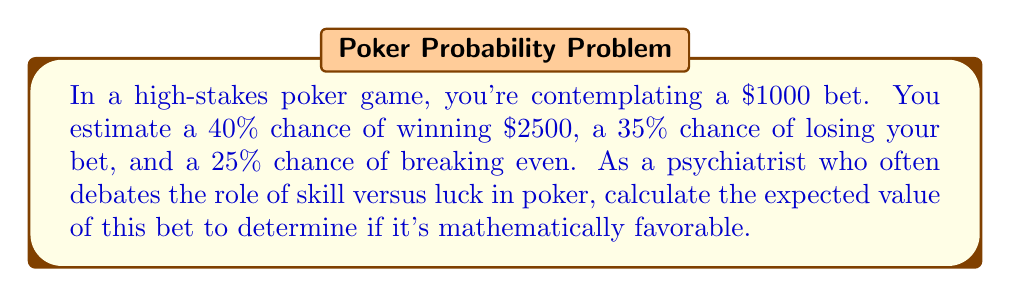Solve this math problem. Let's approach this step-by-step:

1) First, let's define the expected value (EV) formula:
   $$ EV = \sum_{i=1}^n p_i \cdot v_i $$
   where $p_i$ is the probability of each outcome and $v_i$ is the value of each outcome.

2) We have three possible outcomes:
   a) Win: 40% chance of winning $2500
   b) Lose: 35% chance of losing $1000
   c) Break even: 25% chance of neither winning nor losing

3) Let's calculate the value for each outcome:
   a) Win: $2500 - $1000 (initial bet) = $1500 net gain
   b) Lose: -$1000
   c) Break even: $0

4) Now, let's plug these into our expected value formula:
   $$ EV = (0.40 \cdot 1500) + (0.35 \cdot (-1000)) + (0.25 \cdot 0) $$

5) Simplify:
   $$ EV = 600 - 350 + 0 = 250 $$

Therefore, the expected value of this bet is $250.
Answer: $250 